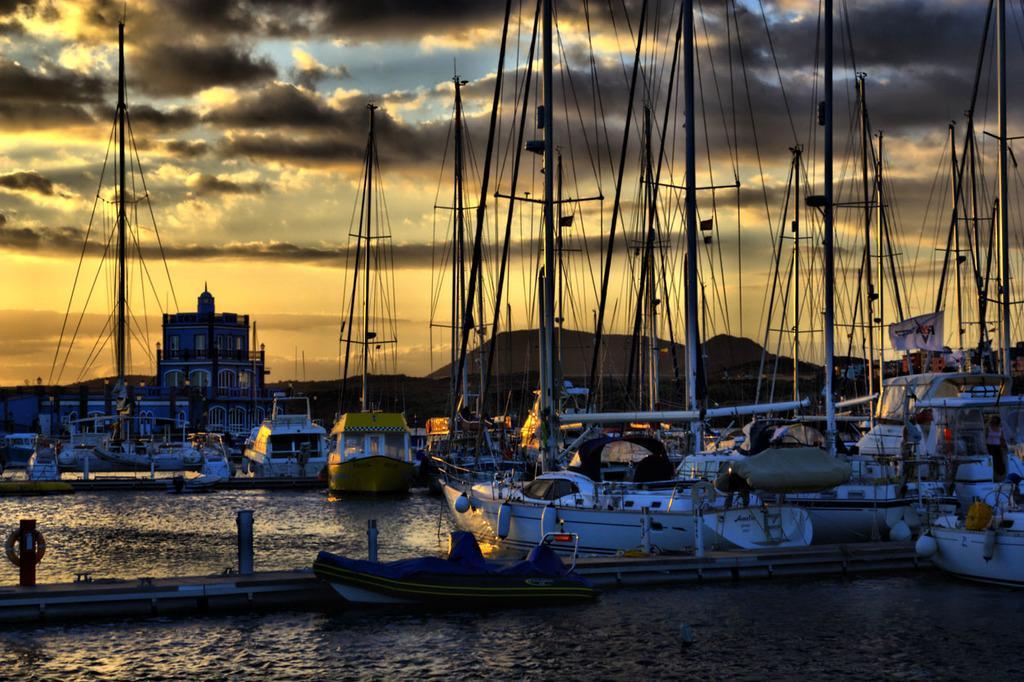Describe this image in one or two sentences. In this image to the bottom there is a river, in that river there are some boats and in the boats there are some people who are sitting. In the background there are some mountains and trees, and also on the top of the image there are some poles and wires and sky. 